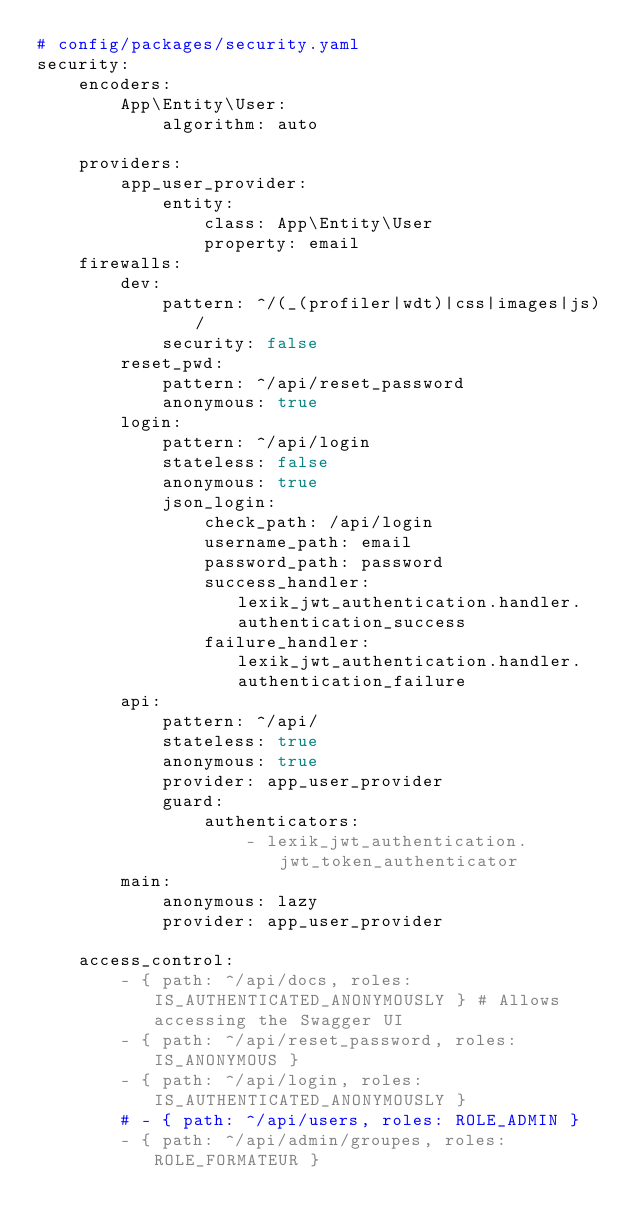<code> <loc_0><loc_0><loc_500><loc_500><_YAML_># config/packages/security.yaml
security:
    encoders:
        App\Entity\User:
            algorithm: auto

    providers:
        app_user_provider:
            entity:
                class: App\Entity\User
                property: email
    firewalls:
        dev:
            pattern: ^/(_(profiler|wdt)|css|images|js)/
            security: false
        reset_pwd: 
            pattern: ^/api/reset_password
            anonymous: true
        login:
            pattern: ^/api/login
            stateless: false
            anonymous: true
            json_login:
                check_path: /api/login
                username_path: email
                password_path: password
                success_handler: lexik_jwt_authentication.handler.authentication_success
                failure_handler: lexik_jwt_authentication.handler.authentication_failure
        api:
            pattern: ^/api/
            stateless: true
            anonymous: true
            provider: app_user_provider
            guard:
                authenticators:
                    - lexik_jwt_authentication.jwt_token_authenticator
        main:
            anonymous: lazy
            provider: app_user_provider

    access_control:
        - { path: ^/api/docs, roles: IS_AUTHENTICATED_ANONYMOUSLY } # Allows accessing the Swagger UI
        - { path: ^/api/reset_password, roles: IS_ANONYMOUS }
        - { path: ^/api/login, roles: IS_AUTHENTICATED_ANONYMOUSLY }
        # - { path: ^/api/users, roles: ROLE_ADMIN }
        - { path: ^/api/admin/groupes, roles: ROLE_FORMATEUR }
</code> 